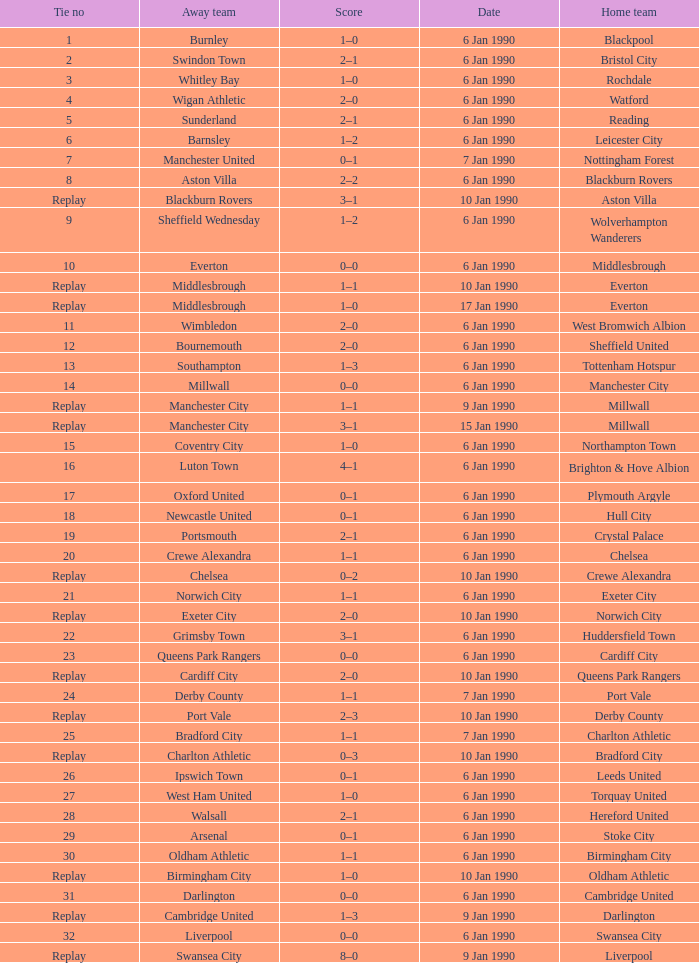What is the tie no of the game where exeter city was the home team? 21.0. 